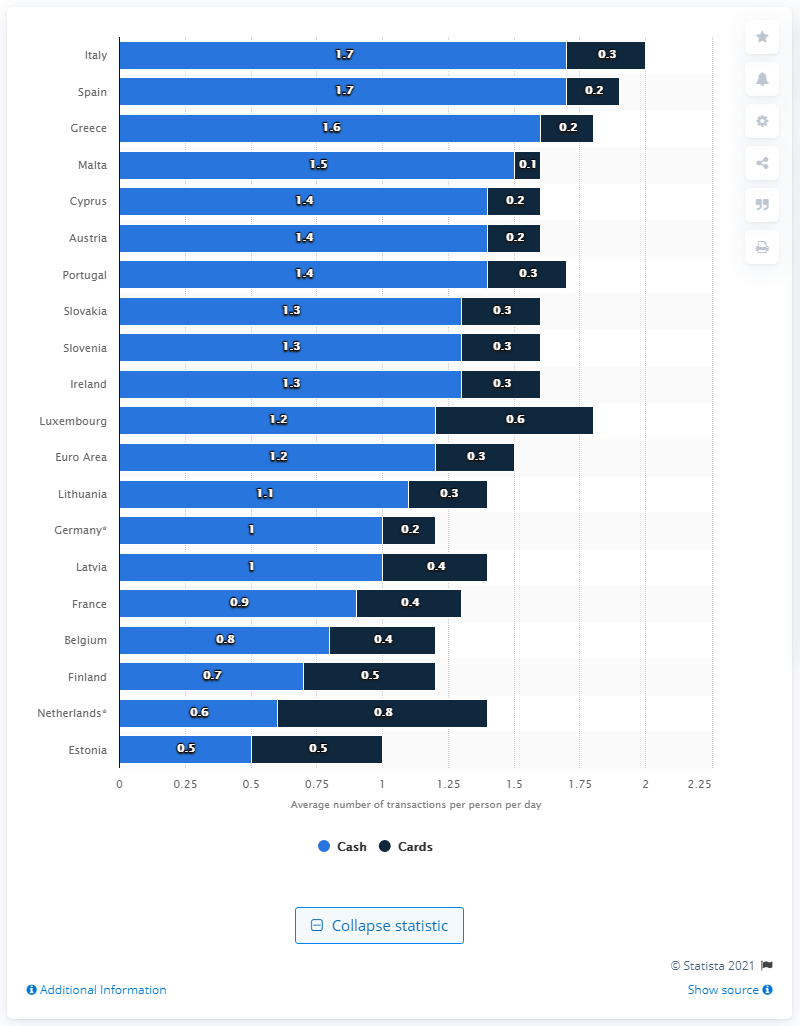Give some essential details in this illustration. In 2016, the average number of transactions per person per day in the Euro area was 1.2. 